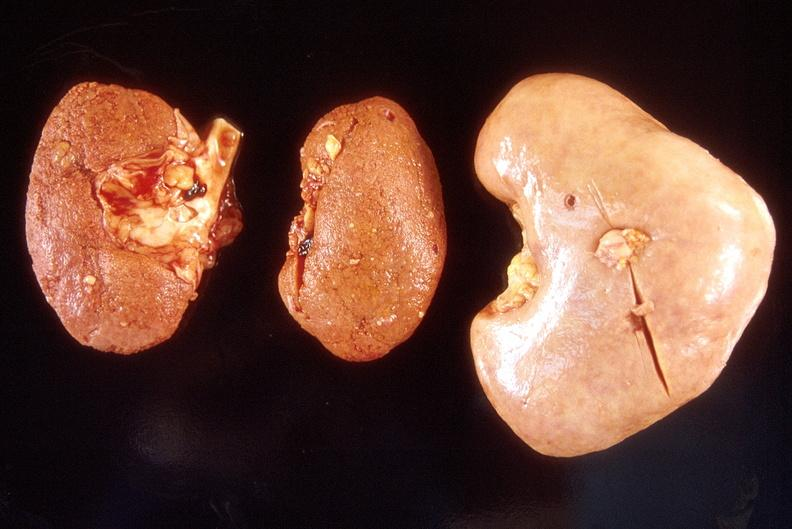does this image show left - native end stage kidneys right - renal allograft abdominal?
Answer the question using a single word or phrase. Yes 